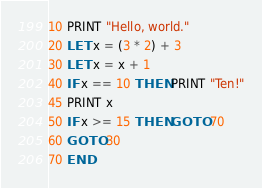<code> <loc_0><loc_0><loc_500><loc_500><_VisualBasic_>10 PRINT "Hello, world."
20 LET x = (3 * 2) + 3
30 LET x = x + 1
40 IF x == 10 THEN PRINT "Ten!"
45 PRINT x
50 IF x >= 15 THEN GOTO 70
60 GOTO 30
70 END
</code> 